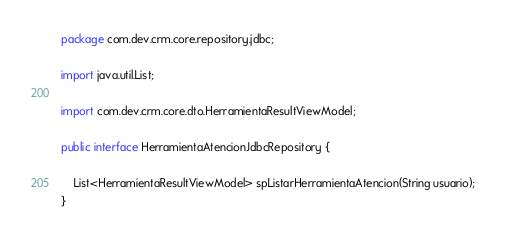Convert code to text. <code><loc_0><loc_0><loc_500><loc_500><_Java_>package com.dev.crm.core.repository.jdbc;

import java.util.List;

import com.dev.crm.core.dto.HerramientaResultViewModel;

public interface HerramientaAtencionJdbcRepository {
	
	List<HerramientaResultViewModel> spListarHerramientaAtencion(String usuario);
}
</code> 